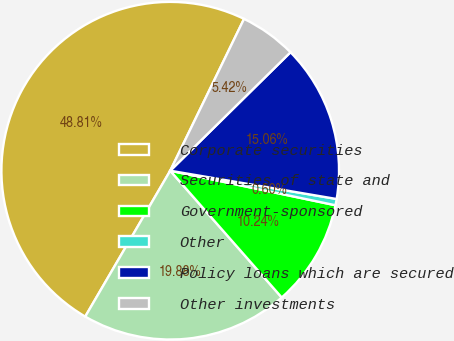<chart> <loc_0><loc_0><loc_500><loc_500><pie_chart><fcel>Corporate securities<fcel>Securities of state and<fcel>Government-sponsored<fcel>Other<fcel>Policy loans which are secured<fcel>Other investments<nl><fcel>48.81%<fcel>19.88%<fcel>10.24%<fcel>0.6%<fcel>15.06%<fcel>5.42%<nl></chart> 